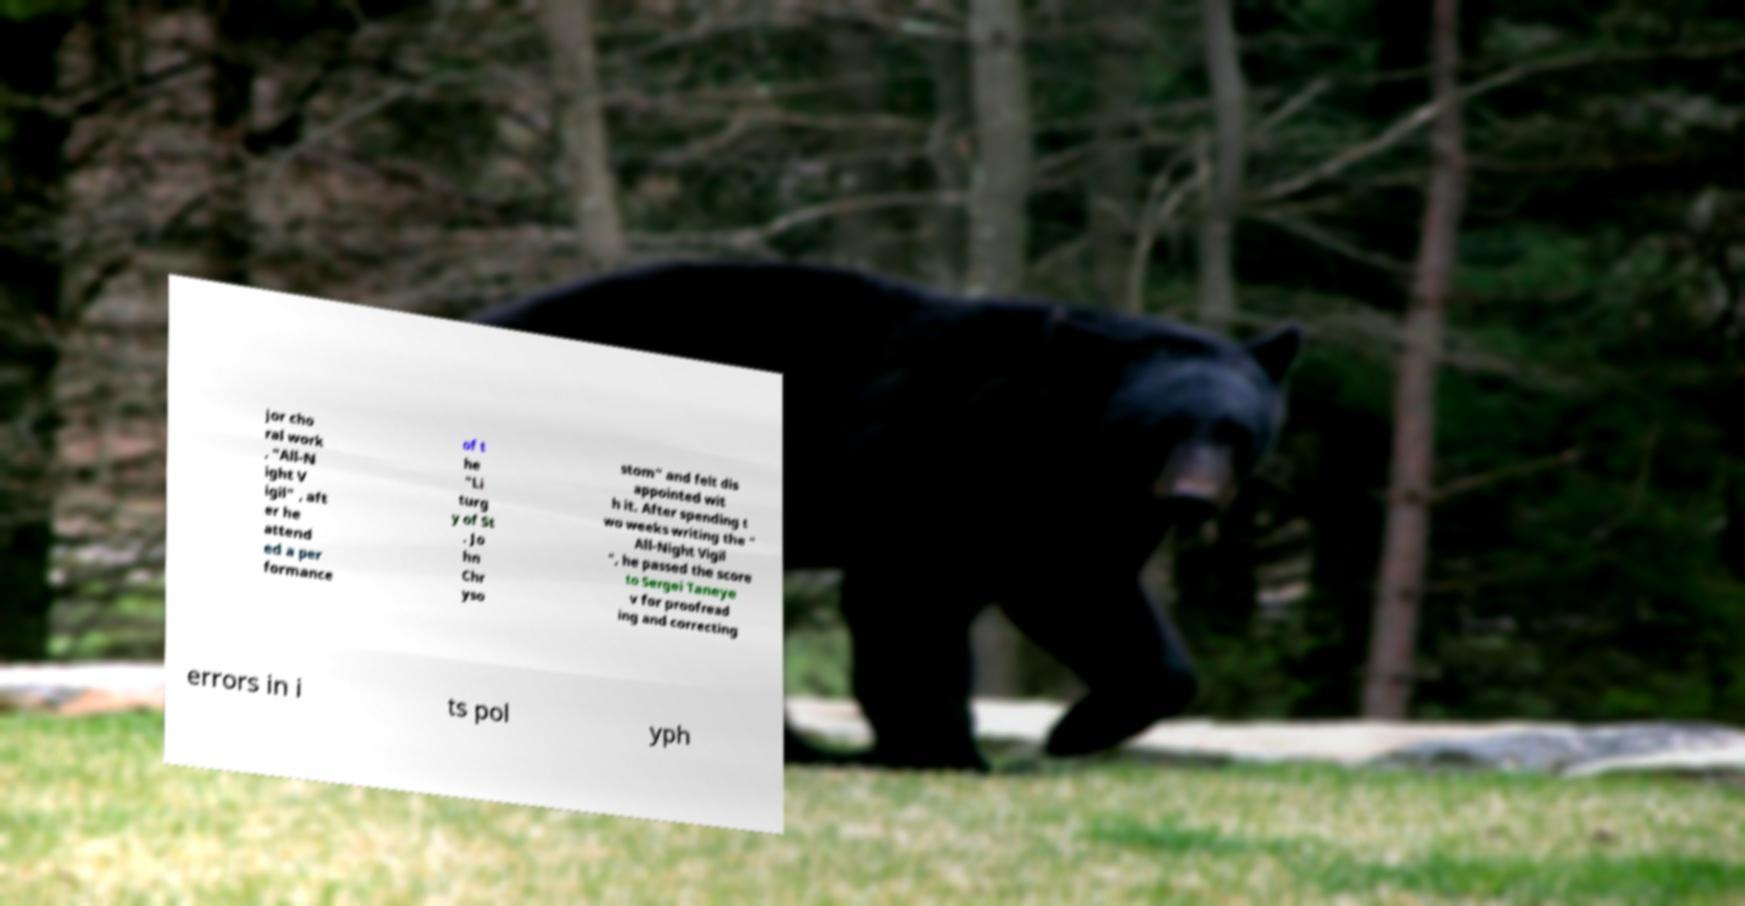Can you accurately transcribe the text from the provided image for me? jor cho ral work , "All-N ight V igil" , aft er he attend ed a per formance of t he "Li turg y of St . Jo hn Chr yso stom" and felt dis appointed wit h it. After spending t wo weeks writing the " All-Night Vigil ", he passed the score to Sergei Taneye v for proofread ing and correcting errors in i ts pol yph 